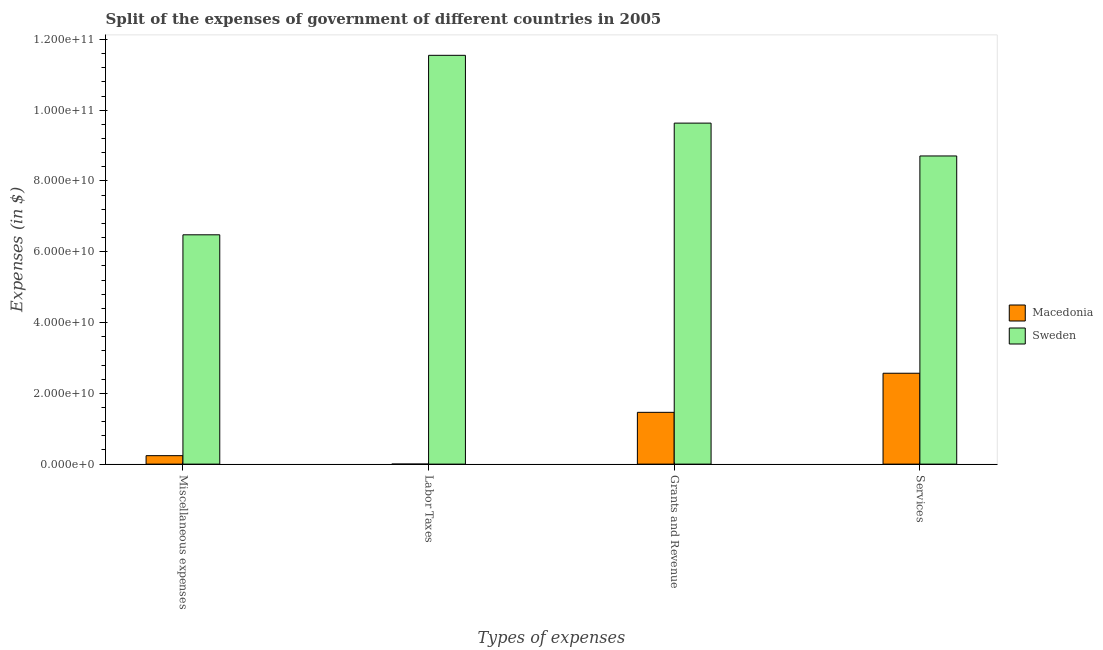How many different coloured bars are there?
Offer a terse response. 2. Are the number of bars per tick equal to the number of legend labels?
Offer a terse response. Yes. Are the number of bars on each tick of the X-axis equal?
Your answer should be very brief. Yes. How many bars are there on the 1st tick from the left?
Your answer should be compact. 2. How many bars are there on the 1st tick from the right?
Your answer should be compact. 2. What is the label of the 2nd group of bars from the left?
Your answer should be very brief. Labor Taxes. What is the amount spent on miscellaneous expenses in Macedonia?
Offer a terse response. 2.39e+09. Across all countries, what is the maximum amount spent on grants and revenue?
Provide a short and direct response. 9.64e+1. Across all countries, what is the minimum amount spent on services?
Your answer should be very brief. 2.57e+1. In which country was the amount spent on services minimum?
Give a very brief answer. Macedonia. What is the total amount spent on services in the graph?
Your answer should be very brief. 1.13e+11. What is the difference between the amount spent on services in Macedonia and that in Sweden?
Your answer should be compact. -6.14e+1. What is the difference between the amount spent on labor taxes in Sweden and the amount spent on services in Macedonia?
Offer a terse response. 8.98e+1. What is the average amount spent on grants and revenue per country?
Provide a short and direct response. 5.55e+1. What is the difference between the amount spent on services and amount spent on miscellaneous expenses in Sweden?
Offer a terse response. 2.23e+1. In how many countries, is the amount spent on grants and revenue greater than 116000000000 $?
Your response must be concise. 0. What is the ratio of the amount spent on grants and revenue in Macedonia to that in Sweden?
Your answer should be compact. 0.15. What is the difference between the highest and the second highest amount spent on labor taxes?
Give a very brief answer. 1.16e+11. What is the difference between the highest and the lowest amount spent on services?
Your response must be concise. 6.14e+1. In how many countries, is the amount spent on grants and revenue greater than the average amount spent on grants and revenue taken over all countries?
Give a very brief answer. 1. Is it the case that in every country, the sum of the amount spent on grants and revenue and amount spent on labor taxes is greater than the sum of amount spent on miscellaneous expenses and amount spent on services?
Keep it short and to the point. No. What does the 2nd bar from the left in Labor Taxes represents?
Keep it short and to the point. Sweden. What does the 1st bar from the right in Labor Taxes represents?
Your answer should be very brief. Sweden. Is it the case that in every country, the sum of the amount spent on miscellaneous expenses and amount spent on labor taxes is greater than the amount spent on grants and revenue?
Offer a very short reply. No. Are all the bars in the graph horizontal?
Your response must be concise. No. What is the difference between two consecutive major ticks on the Y-axis?
Provide a succinct answer. 2.00e+1. Are the values on the major ticks of Y-axis written in scientific E-notation?
Give a very brief answer. Yes. Does the graph contain any zero values?
Offer a terse response. No. Does the graph contain grids?
Provide a succinct answer. No. Where does the legend appear in the graph?
Keep it short and to the point. Center right. How many legend labels are there?
Make the answer very short. 2. How are the legend labels stacked?
Provide a succinct answer. Vertical. What is the title of the graph?
Give a very brief answer. Split of the expenses of government of different countries in 2005. What is the label or title of the X-axis?
Offer a very short reply. Types of expenses. What is the label or title of the Y-axis?
Give a very brief answer. Expenses (in $). What is the Expenses (in $) of Macedonia in Miscellaneous expenses?
Your answer should be very brief. 2.39e+09. What is the Expenses (in $) of Sweden in Miscellaneous expenses?
Give a very brief answer. 6.48e+1. What is the Expenses (in $) in Macedonia in Labor Taxes?
Ensure brevity in your answer.  5.64e+06. What is the Expenses (in $) of Sweden in Labor Taxes?
Provide a short and direct response. 1.16e+11. What is the Expenses (in $) in Macedonia in Grants and Revenue?
Provide a short and direct response. 1.46e+1. What is the Expenses (in $) of Sweden in Grants and Revenue?
Give a very brief answer. 9.64e+1. What is the Expenses (in $) in Macedonia in Services?
Make the answer very short. 2.57e+1. What is the Expenses (in $) of Sweden in Services?
Give a very brief answer. 8.71e+1. Across all Types of expenses, what is the maximum Expenses (in $) in Macedonia?
Your answer should be compact. 2.57e+1. Across all Types of expenses, what is the maximum Expenses (in $) in Sweden?
Make the answer very short. 1.16e+11. Across all Types of expenses, what is the minimum Expenses (in $) in Macedonia?
Ensure brevity in your answer.  5.64e+06. Across all Types of expenses, what is the minimum Expenses (in $) in Sweden?
Provide a succinct answer. 6.48e+1. What is the total Expenses (in $) in Macedonia in the graph?
Your answer should be very brief. 4.27e+1. What is the total Expenses (in $) in Sweden in the graph?
Offer a very short reply. 3.64e+11. What is the difference between the Expenses (in $) in Macedonia in Miscellaneous expenses and that in Labor Taxes?
Offer a very short reply. 2.38e+09. What is the difference between the Expenses (in $) in Sweden in Miscellaneous expenses and that in Labor Taxes?
Ensure brevity in your answer.  -5.07e+1. What is the difference between the Expenses (in $) of Macedonia in Miscellaneous expenses and that in Grants and Revenue?
Keep it short and to the point. -1.22e+1. What is the difference between the Expenses (in $) in Sweden in Miscellaneous expenses and that in Grants and Revenue?
Give a very brief answer. -3.16e+1. What is the difference between the Expenses (in $) in Macedonia in Miscellaneous expenses and that in Services?
Your response must be concise. -2.33e+1. What is the difference between the Expenses (in $) of Sweden in Miscellaneous expenses and that in Services?
Provide a short and direct response. -2.23e+1. What is the difference between the Expenses (in $) in Macedonia in Labor Taxes and that in Grants and Revenue?
Offer a very short reply. -1.46e+1. What is the difference between the Expenses (in $) of Sweden in Labor Taxes and that in Grants and Revenue?
Ensure brevity in your answer.  1.92e+1. What is the difference between the Expenses (in $) in Macedonia in Labor Taxes and that in Services?
Provide a succinct answer. -2.57e+1. What is the difference between the Expenses (in $) in Sweden in Labor Taxes and that in Services?
Offer a very short reply. 2.84e+1. What is the difference between the Expenses (in $) in Macedonia in Grants and Revenue and that in Services?
Offer a very short reply. -1.10e+1. What is the difference between the Expenses (in $) of Sweden in Grants and Revenue and that in Services?
Give a very brief answer. 9.28e+09. What is the difference between the Expenses (in $) in Macedonia in Miscellaneous expenses and the Expenses (in $) in Sweden in Labor Taxes?
Keep it short and to the point. -1.13e+11. What is the difference between the Expenses (in $) in Macedonia in Miscellaneous expenses and the Expenses (in $) in Sweden in Grants and Revenue?
Provide a short and direct response. -9.40e+1. What is the difference between the Expenses (in $) in Macedonia in Miscellaneous expenses and the Expenses (in $) in Sweden in Services?
Your response must be concise. -8.47e+1. What is the difference between the Expenses (in $) of Macedonia in Labor Taxes and the Expenses (in $) of Sweden in Grants and Revenue?
Your response must be concise. -9.63e+1. What is the difference between the Expenses (in $) in Macedonia in Labor Taxes and the Expenses (in $) in Sweden in Services?
Make the answer very short. -8.71e+1. What is the difference between the Expenses (in $) in Macedonia in Grants and Revenue and the Expenses (in $) in Sweden in Services?
Ensure brevity in your answer.  -7.24e+1. What is the average Expenses (in $) in Macedonia per Types of expenses?
Provide a short and direct response. 1.07e+1. What is the average Expenses (in $) of Sweden per Types of expenses?
Your response must be concise. 9.09e+1. What is the difference between the Expenses (in $) in Macedonia and Expenses (in $) in Sweden in Miscellaneous expenses?
Offer a very short reply. -6.24e+1. What is the difference between the Expenses (in $) in Macedonia and Expenses (in $) in Sweden in Labor Taxes?
Ensure brevity in your answer.  -1.16e+11. What is the difference between the Expenses (in $) of Macedonia and Expenses (in $) of Sweden in Grants and Revenue?
Offer a very short reply. -8.17e+1. What is the difference between the Expenses (in $) of Macedonia and Expenses (in $) of Sweden in Services?
Give a very brief answer. -6.14e+1. What is the ratio of the Expenses (in $) of Macedonia in Miscellaneous expenses to that in Labor Taxes?
Provide a succinct answer. 422.86. What is the ratio of the Expenses (in $) of Sweden in Miscellaneous expenses to that in Labor Taxes?
Offer a very short reply. 0.56. What is the ratio of the Expenses (in $) in Macedonia in Miscellaneous expenses to that in Grants and Revenue?
Your answer should be very brief. 0.16. What is the ratio of the Expenses (in $) of Sweden in Miscellaneous expenses to that in Grants and Revenue?
Provide a short and direct response. 0.67. What is the ratio of the Expenses (in $) in Macedonia in Miscellaneous expenses to that in Services?
Provide a succinct answer. 0.09. What is the ratio of the Expenses (in $) in Sweden in Miscellaneous expenses to that in Services?
Offer a terse response. 0.74. What is the ratio of the Expenses (in $) of Sweden in Labor Taxes to that in Grants and Revenue?
Keep it short and to the point. 1.2. What is the ratio of the Expenses (in $) in Sweden in Labor Taxes to that in Services?
Offer a very short reply. 1.33. What is the ratio of the Expenses (in $) of Macedonia in Grants and Revenue to that in Services?
Offer a terse response. 0.57. What is the ratio of the Expenses (in $) in Sweden in Grants and Revenue to that in Services?
Make the answer very short. 1.11. What is the difference between the highest and the second highest Expenses (in $) in Macedonia?
Provide a succinct answer. 1.10e+1. What is the difference between the highest and the second highest Expenses (in $) in Sweden?
Your answer should be very brief. 1.92e+1. What is the difference between the highest and the lowest Expenses (in $) of Macedonia?
Provide a succinct answer. 2.57e+1. What is the difference between the highest and the lowest Expenses (in $) in Sweden?
Offer a terse response. 5.07e+1. 